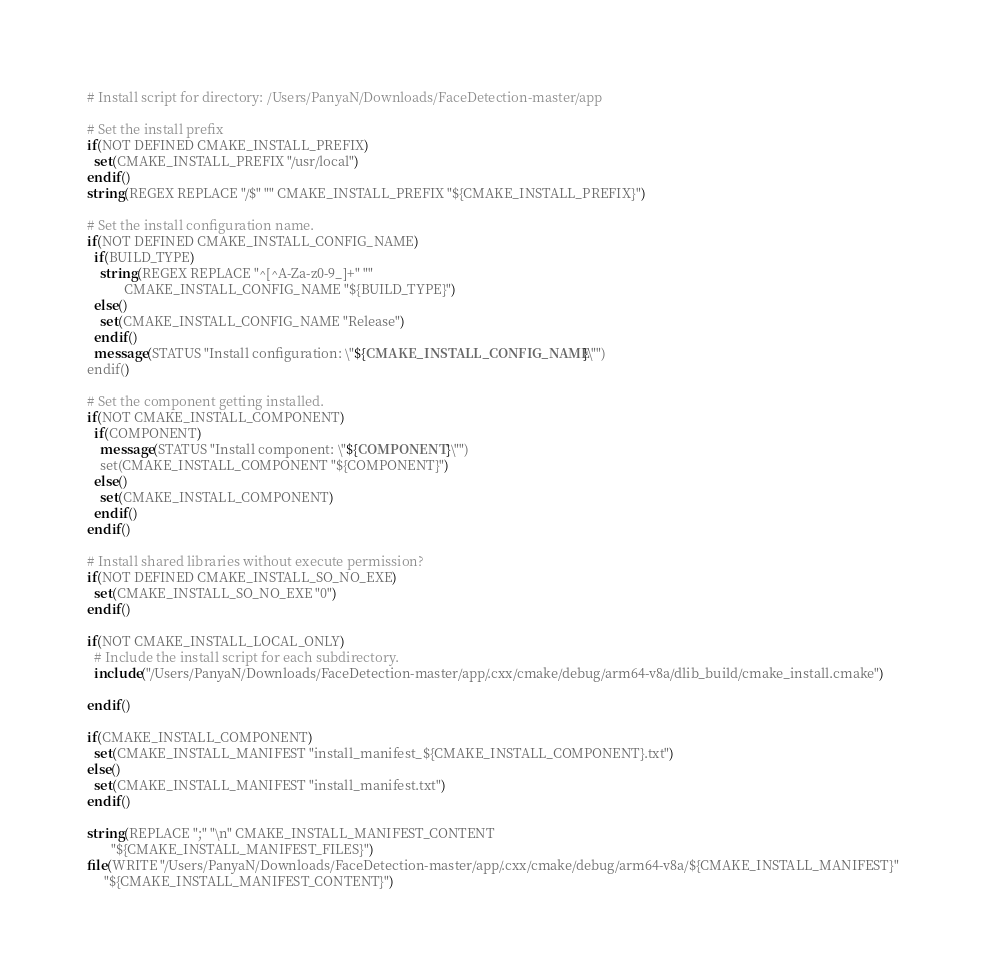<code> <loc_0><loc_0><loc_500><loc_500><_CMake_># Install script for directory: /Users/PanyaN/Downloads/FaceDetection-master/app

# Set the install prefix
if(NOT DEFINED CMAKE_INSTALL_PREFIX)
  set(CMAKE_INSTALL_PREFIX "/usr/local")
endif()
string(REGEX REPLACE "/$" "" CMAKE_INSTALL_PREFIX "${CMAKE_INSTALL_PREFIX}")

# Set the install configuration name.
if(NOT DEFINED CMAKE_INSTALL_CONFIG_NAME)
  if(BUILD_TYPE)
    string(REGEX REPLACE "^[^A-Za-z0-9_]+" ""
           CMAKE_INSTALL_CONFIG_NAME "${BUILD_TYPE}")
  else()
    set(CMAKE_INSTALL_CONFIG_NAME "Release")
  endif()
  message(STATUS "Install configuration: \"${CMAKE_INSTALL_CONFIG_NAME}\"")
endif()

# Set the component getting installed.
if(NOT CMAKE_INSTALL_COMPONENT)
  if(COMPONENT)
    message(STATUS "Install component: \"${COMPONENT}\"")
    set(CMAKE_INSTALL_COMPONENT "${COMPONENT}")
  else()
    set(CMAKE_INSTALL_COMPONENT)
  endif()
endif()

# Install shared libraries without execute permission?
if(NOT DEFINED CMAKE_INSTALL_SO_NO_EXE)
  set(CMAKE_INSTALL_SO_NO_EXE "0")
endif()

if(NOT CMAKE_INSTALL_LOCAL_ONLY)
  # Include the install script for each subdirectory.
  include("/Users/PanyaN/Downloads/FaceDetection-master/app/.cxx/cmake/debug/arm64-v8a/dlib_build/cmake_install.cmake")

endif()

if(CMAKE_INSTALL_COMPONENT)
  set(CMAKE_INSTALL_MANIFEST "install_manifest_${CMAKE_INSTALL_COMPONENT}.txt")
else()
  set(CMAKE_INSTALL_MANIFEST "install_manifest.txt")
endif()

string(REPLACE ";" "\n" CMAKE_INSTALL_MANIFEST_CONTENT
       "${CMAKE_INSTALL_MANIFEST_FILES}")
file(WRITE "/Users/PanyaN/Downloads/FaceDetection-master/app/.cxx/cmake/debug/arm64-v8a/${CMAKE_INSTALL_MANIFEST}"
     "${CMAKE_INSTALL_MANIFEST_CONTENT}")
</code> 